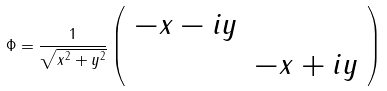Convert formula to latex. <formula><loc_0><loc_0><loc_500><loc_500>\Phi = \frac { 1 } { \sqrt { x ^ { 2 } + y ^ { 2 } } } \left ( \begin{array} { c c } - x - i y & \\ & - x + i y \end{array} \right )</formula> 